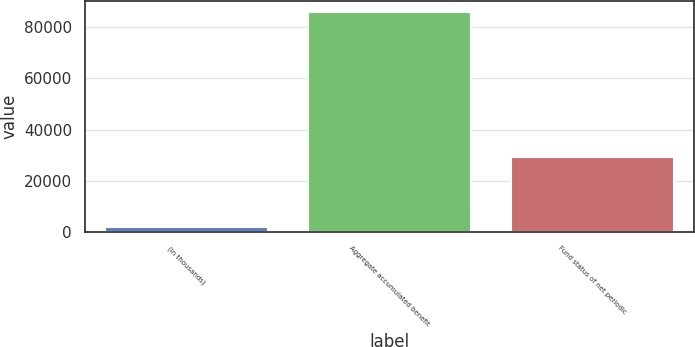Convert chart. <chart><loc_0><loc_0><loc_500><loc_500><bar_chart><fcel>(in thousands)<fcel>Aggregate accumulated benefit<fcel>Fund status of net periodic<nl><fcel>2002<fcel>86083<fcel>29423<nl></chart> 